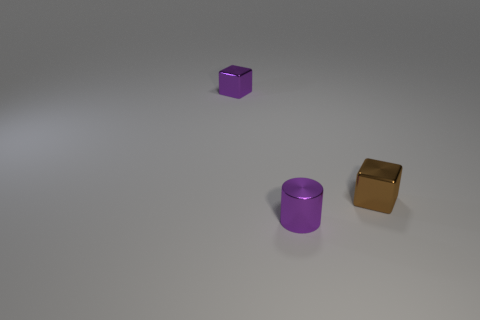Which object seems to be closest to the point of view, and what does its surface texture look like? The closest object to the point of view is the cylindrical object in the foreground. It has a matte surface with a smooth appearance, and it's distinctly less reflective in comparison to the gold-colored cylinder. Is there anything notable about the lighting or shadows in the scene? The lighting in the scene appears diffuse, casting soft shadows that suggest an overhead light source with minimal harshness. The subtle shadows contribute to the overall calm and minimalistic ambiance of the image. 